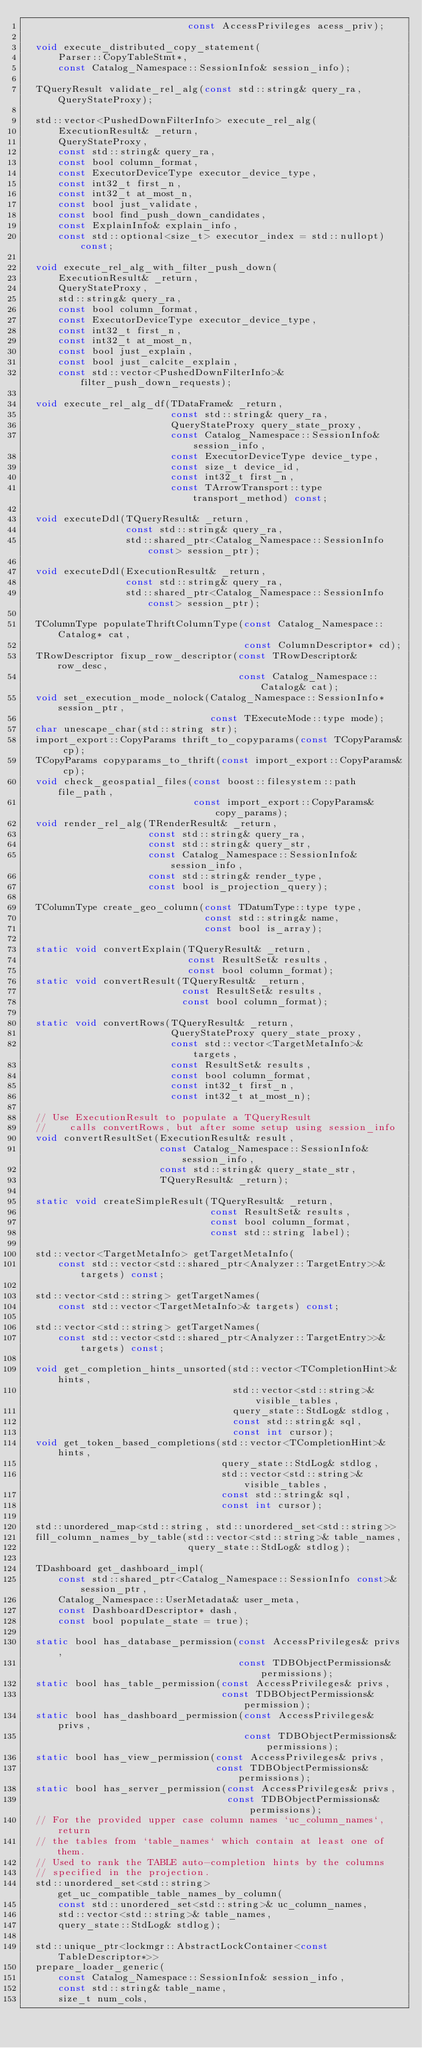Convert code to text. <code><loc_0><loc_0><loc_500><loc_500><_C_>                             const AccessPrivileges acess_priv);

  void execute_distributed_copy_statement(
      Parser::CopyTableStmt*,
      const Catalog_Namespace::SessionInfo& session_info);

  TQueryResult validate_rel_alg(const std::string& query_ra, QueryStateProxy);

  std::vector<PushedDownFilterInfo> execute_rel_alg(
      ExecutionResult& _return,
      QueryStateProxy,
      const std::string& query_ra,
      const bool column_format,
      const ExecutorDeviceType executor_device_type,
      const int32_t first_n,
      const int32_t at_most_n,
      const bool just_validate,
      const bool find_push_down_candidates,
      const ExplainInfo& explain_info,
      const std::optional<size_t> executor_index = std::nullopt) const;

  void execute_rel_alg_with_filter_push_down(
      ExecutionResult& _return,
      QueryStateProxy,
      std::string& query_ra,
      const bool column_format,
      const ExecutorDeviceType executor_device_type,
      const int32_t first_n,
      const int32_t at_most_n,
      const bool just_explain,
      const bool just_calcite_explain,
      const std::vector<PushedDownFilterInfo>& filter_push_down_requests);

  void execute_rel_alg_df(TDataFrame& _return,
                          const std::string& query_ra,
                          QueryStateProxy query_state_proxy,
                          const Catalog_Namespace::SessionInfo& session_info,
                          const ExecutorDeviceType device_type,
                          const size_t device_id,
                          const int32_t first_n,
                          const TArrowTransport::type transport_method) const;

  void executeDdl(TQueryResult& _return,
                  const std::string& query_ra,
                  std::shared_ptr<Catalog_Namespace::SessionInfo const> session_ptr);

  void executeDdl(ExecutionResult& _return,
                  const std::string& query_ra,
                  std::shared_ptr<Catalog_Namespace::SessionInfo const> session_ptr);

  TColumnType populateThriftColumnType(const Catalog_Namespace::Catalog* cat,
                                       const ColumnDescriptor* cd);
  TRowDescriptor fixup_row_descriptor(const TRowDescriptor& row_desc,
                                      const Catalog_Namespace::Catalog& cat);
  void set_execution_mode_nolock(Catalog_Namespace::SessionInfo* session_ptr,
                                 const TExecuteMode::type mode);
  char unescape_char(std::string str);
  import_export::CopyParams thrift_to_copyparams(const TCopyParams& cp);
  TCopyParams copyparams_to_thrift(const import_export::CopyParams& cp);
  void check_geospatial_files(const boost::filesystem::path file_path,
                              const import_export::CopyParams& copy_params);
  void render_rel_alg(TRenderResult& _return,
                      const std::string& query_ra,
                      const std::string& query_str,
                      const Catalog_Namespace::SessionInfo& session_info,
                      const std::string& render_type,
                      const bool is_projection_query);

  TColumnType create_geo_column(const TDatumType::type type,
                                const std::string& name,
                                const bool is_array);

  static void convertExplain(TQueryResult& _return,
                             const ResultSet& results,
                             const bool column_format);
  static void convertResult(TQueryResult& _return,
                            const ResultSet& results,
                            const bool column_format);

  static void convertRows(TQueryResult& _return,
                          QueryStateProxy query_state_proxy,
                          const std::vector<TargetMetaInfo>& targets,
                          const ResultSet& results,
                          const bool column_format,
                          const int32_t first_n,
                          const int32_t at_most_n);

  // Use ExecutionResult to populate a TQueryResult
  //    calls convertRows, but after some setup using session_info
  void convertResultSet(ExecutionResult& result,
                        const Catalog_Namespace::SessionInfo& session_info,
                        const std::string& query_state_str,
                        TQueryResult& _return);

  static void createSimpleResult(TQueryResult& _return,
                                 const ResultSet& results,
                                 const bool column_format,
                                 const std::string label);

  std::vector<TargetMetaInfo> getTargetMetaInfo(
      const std::vector<std::shared_ptr<Analyzer::TargetEntry>>& targets) const;

  std::vector<std::string> getTargetNames(
      const std::vector<TargetMetaInfo>& targets) const;

  std::vector<std::string> getTargetNames(
      const std::vector<std::shared_ptr<Analyzer::TargetEntry>>& targets) const;

  void get_completion_hints_unsorted(std::vector<TCompletionHint>& hints,
                                     std::vector<std::string>& visible_tables,
                                     query_state::StdLog& stdlog,
                                     const std::string& sql,
                                     const int cursor);
  void get_token_based_completions(std::vector<TCompletionHint>& hints,
                                   query_state::StdLog& stdlog,
                                   std::vector<std::string>& visible_tables,
                                   const std::string& sql,
                                   const int cursor);

  std::unordered_map<std::string, std::unordered_set<std::string>>
  fill_column_names_by_table(std::vector<std::string>& table_names,
                             query_state::StdLog& stdlog);

  TDashboard get_dashboard_impl(
      const std::shared_ptr<Catalog_Namespace::SessionInfo const>& session_ptr,
      Catalog_Namespace::UserMetadata& user_meta,
      const DashboardDescriptor* dash,
      const bool populate_state = true);

  static bool has_database_permission(const AccessPrivileges& privs,
                                      const TDBObjectPermissions& permissions);
  static bool has_table_permission(const AccessPrivileges& privs,
                                   const TDBObjectPermissions& permission);
  static bool has_dashboard_permission(const AccessPrivileges& privs,
                                       const TDBObjectPermissions& permissions);
  static bool has_view_permission(const AccessPrivileges& privs,
                                  const TDBObjectPermissions& permissions);
  static bool has_server_permission(const AccessPrivileges& privs,
                                    const TDBObjectPermissions& permissions);
  // For the provided upper case column names `uc_column_names`, return
  // the tables from `table_names` which contain at least one of them.
  // Used to rank the TABLE auto-completion hints by the columns
  // specified in the projection.
  std::unordered_set<std::string> get_uc_compatible_table_names_by_column(
      const std::unordered_set<std::string>& uc_column_names,
      std::vector<std::string>& table_names,
      query_state::StdLog& stdlog);

  std::unique_ptr<lockmgr::AbstractLockContainer<const TableDescriptor*>>
  prepare_loader_generic(
      const Catalog_Namespace::SessionInfo& session_info,
      const std::string& table_name,
      size_t num_cols,</code> 